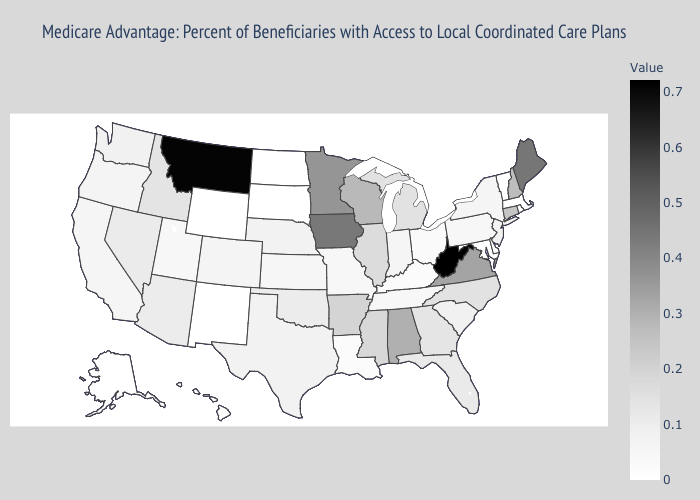Does California have the highest value in the USA?
Be succinct. No. Does Colorado have the highest value in the USA?
Give a very brief answer. No. Does Nevada have the highest value in the USA?
Short answer required. No. Does Pennsylvania have the lowest value in the Northeast?
Give a very brief answer. No. Which states have the highest value in the USA?
Be succinct. West Virginia. 